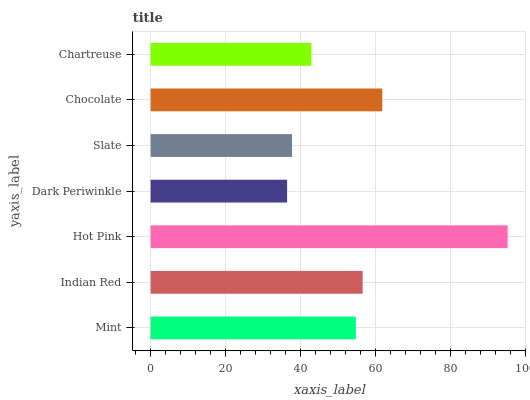Is Dark Periwinkle the minimum?
Answer yes or no. Yes. Is Hot Pink the maximum?
Answer yes or no. Yes. Is Indian Red the minimum?
Answer yes or no. No. Is Indian Red the maximum?
Answer yes or no. No. Is Indian Red greater than Mint?
Answer yes or no. Yes. Is Mint less than Indian Red?
Answer yes or no. Yes. Is Mint greater than Indian Red?
Answer yes or no. No. Is Indian Red less than Mint?
Answer yes or no. No. Is Mint the high median?
Answer yes or no. Yes. Is Mint the low median?
Answer yes or no. Yes. Is Indian Red the high median?
Answer yes or no. No. Is Indian Red the low median?
Answer yes or no. No. 